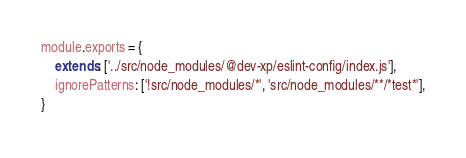<code> <loc_0><loc_0><loc_500><loc_500><_JavaScript_>module.exports = {
    extends: ['../src/node_modules/@dev-xp/eslint-config/index.js'],
    ignorePatterns: ['!src/node_modules/*', 'src/node_modules/**/*test*'],
}
</code> 